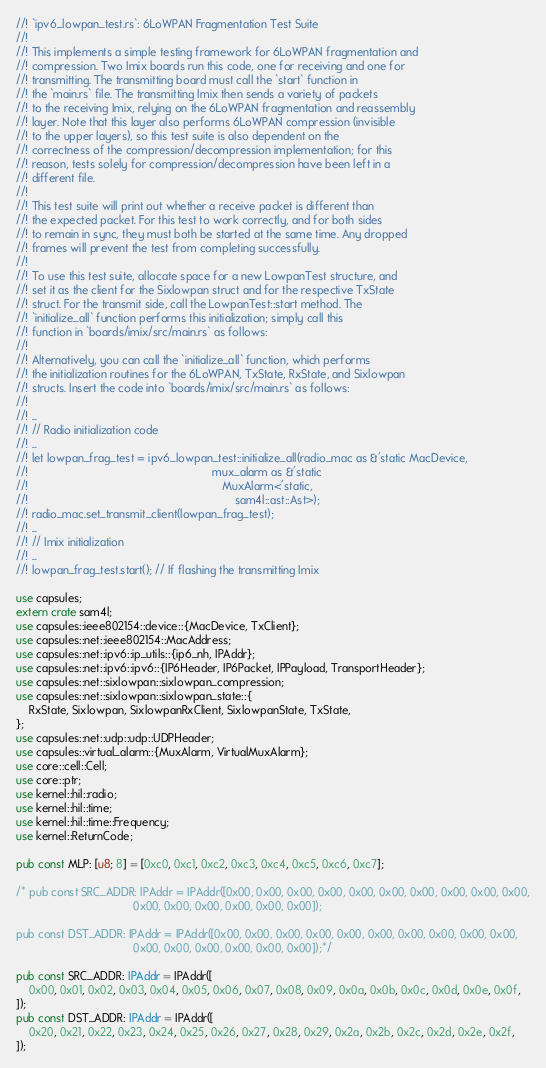<code> <loc_0><loc_0><loc_500><loc_500><_Rust_>//! `ipv6_lowpan_test.rs`: 6LoWPAN Fragmentation Test Suite
//!
//! This implements a simple testing framework for 6LoWPAN fragmentation and
//! compression. Two Imix boards run this code, one for receiving and one for
//! transmitting. The transmitting board must call the `start` function in
//! the `main.rs` file. The transmitting Imix then sends a variety of packets
//! to the receiving Imix, relying on the 6LoWPAN fragmentation and reassembly
//! layer. Note that this layer also performs 6LoWPAN compression (invisible
//! to the upper layers), so this test suite is also dependent on the
//! correctness of the compression/decompression implementation; for this
//! reason, tests solely for compression/decompression have been left in a
//! different file.
//!
//! This test suite will print out whether a receive packet is different than
//! the expected packet. For this test to work correctly, and for both sides
//! to remain in sync, they must both be started at the same time. Any dropped
//! frames will prevent the test from completing successfully.
//!
//! To use this test suite, allocate space for a new LowpanTest structure, and
//! set it as the client for the Sixlowpan struct and for the respective TxState
//! struct. For the transmit side, call the LowpanTest::start method. The
//! `initialize_all` function performs this initialization; simply call this
//! function in `boards/imix/src/main.rs` as follows:
//!
//! Alternatively, you can call the `initialize_all` function, which performs
//! the initialization routines for the 6LoWPAN, TxState, RxState, and Sixlowpan
//! structs. Insert the code into `boards/imix/src/main.rs` as follows:
//!
//! ...
//! // Radio initialization code
//! ...
//! let lowpan_frag_test = ipv6_lowpan_test::initialize_all(radio_mac as &'static MacDevice,
//!                                                          mux_alarm as &'static
//!                                                             MuxAlarm<'static,
//!                                                                 sam4l::ast::Ast>);
//! radio_mac.set_transmit_client(lowpan_frag_test);
//! ...
//! // Imix initialization
//! ...
//! lowpan_frag_test.start(); // If flashing the transmitting Imix

use capsules;
extern crate sam4l;
use capsules::ieee802154::device::{MacDevice, TxClient};
use capsules::net::ieee802154::MacAddress;
use capsules::net::ipv6::ip_utils::{ip6_nh, IPAddr};
use capsules::net::ipv6::ipv6::{IP6Header, IP6Packet, IPPayload, TransportHeader};
use capsules::net::sixlowpan::sixlowpan_compression;
use capsules::net::sixlowpan::sixlowpan_state::{
    RxState, Sixlowpan, SixlowpanRxClient, SixlowpanState, TxState,
};
use capsules::net::udp::udp::UDPHeader;
use capsules::virtual_alarm::{MuxAlarm, VirtualMuxAlarm};
use core::cell::Cell;
use core::ptr;
use kernel::hil::radio;
use kernel::hil::time;
use kernel::hil::time::Frequency;
use kernel::ReturnCode;

pub const MLP: [u8; 8] = [0xc0, 0xc1, 0xc2, 0xc3, 0xc4, 0xc5, 0xc6, 0xc7];

/* pub const SRC_ADDR: IPAddr = IPAddr([0x00, 0x00, 0x00, 0x00, 0x00, 0x00, 0x00, 0x00, 0x00, 0x00,
                                     0x00, 0x00, 0x00, 0x00, 0x00, 0x00]);

pub const DST_ADDR: IPAddr = IPAddr([0x00, 0x00, 0x00, 0x00, 0x00, 0x00, 0x00, 0x00, 0x00, 0x00,
                                     0x00, 0x00, 0x00, 0x00, 0x00, 0x00]);*/

pub const SRC_ADDR: IPAddr = IPAddr([
    0x00, 0x01, 0x02, 0x03, 0x04, 0x05, 0x06, 0x07, 0x08, 0x09, 0x0a, 0x0b, 0x0c, 0x0d, 0x0e, 0x0f,
]);
pub const DST_ADDR: IPAddr = IPAddr([
    0x20, 0x21, 0x22, 0x23, 0x24, 0x25, 0x26, 0x27, 0x28, 0x29, 0x2a, 0x2b, 0x2c, 0x2d, 0x2e, 0x2f,
]);</code> 